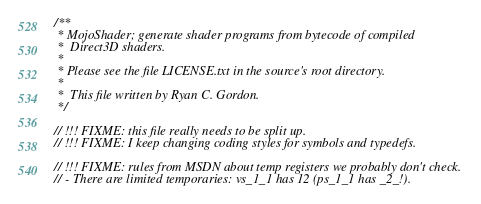Convert code to text. <code><loc_0><loc_0><loc_500><loc_500><_C_>/**
 * MojoShader; generate shader programs from bytecode of compiled
 *  Direct3D shaders.
 *
 * Please see the file LICENSE.txt in the source's root directory.
 *
 *  This file written by Ryan C. Gordon.
 */

// !!! FIXME: this file really needs to be split up.
// !!! FIXME: I keep changing coding styles for symbols and typedefs.

// !!! FIXME: rules from MSDN about temp registers we probably don't check.
// - There are limited temporaries: vs_1_1 has 12 (ps_1_1 has _2_!).</code> 